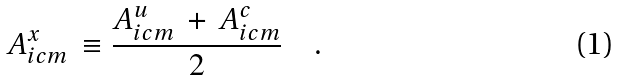<formula> <loc_0><loc_0><loc_500><loc_500>A _ { i c m } ^ { x } \, \equiv \frac { A _ { i c m } ^ { u } \, + \, A _ { i c m } ^ { c } } { 2 } \quad .</formula> 